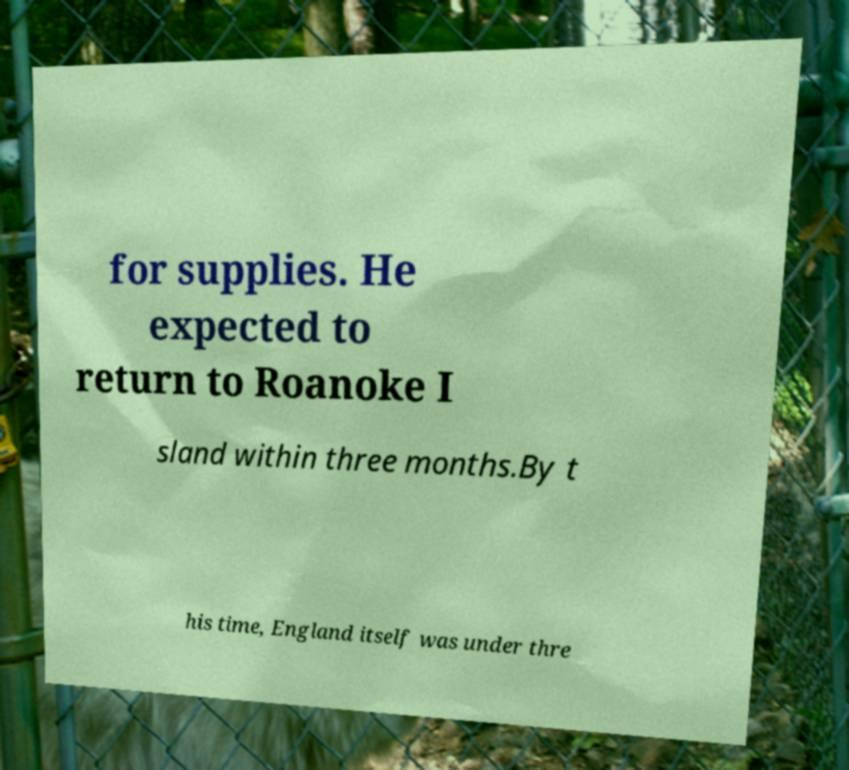For documentation purposes, I need the text within this image transcribed. Could you provide that? for supplies. He expected to return to Roanoke I sland within three months.By t his time, England itself was under thre 